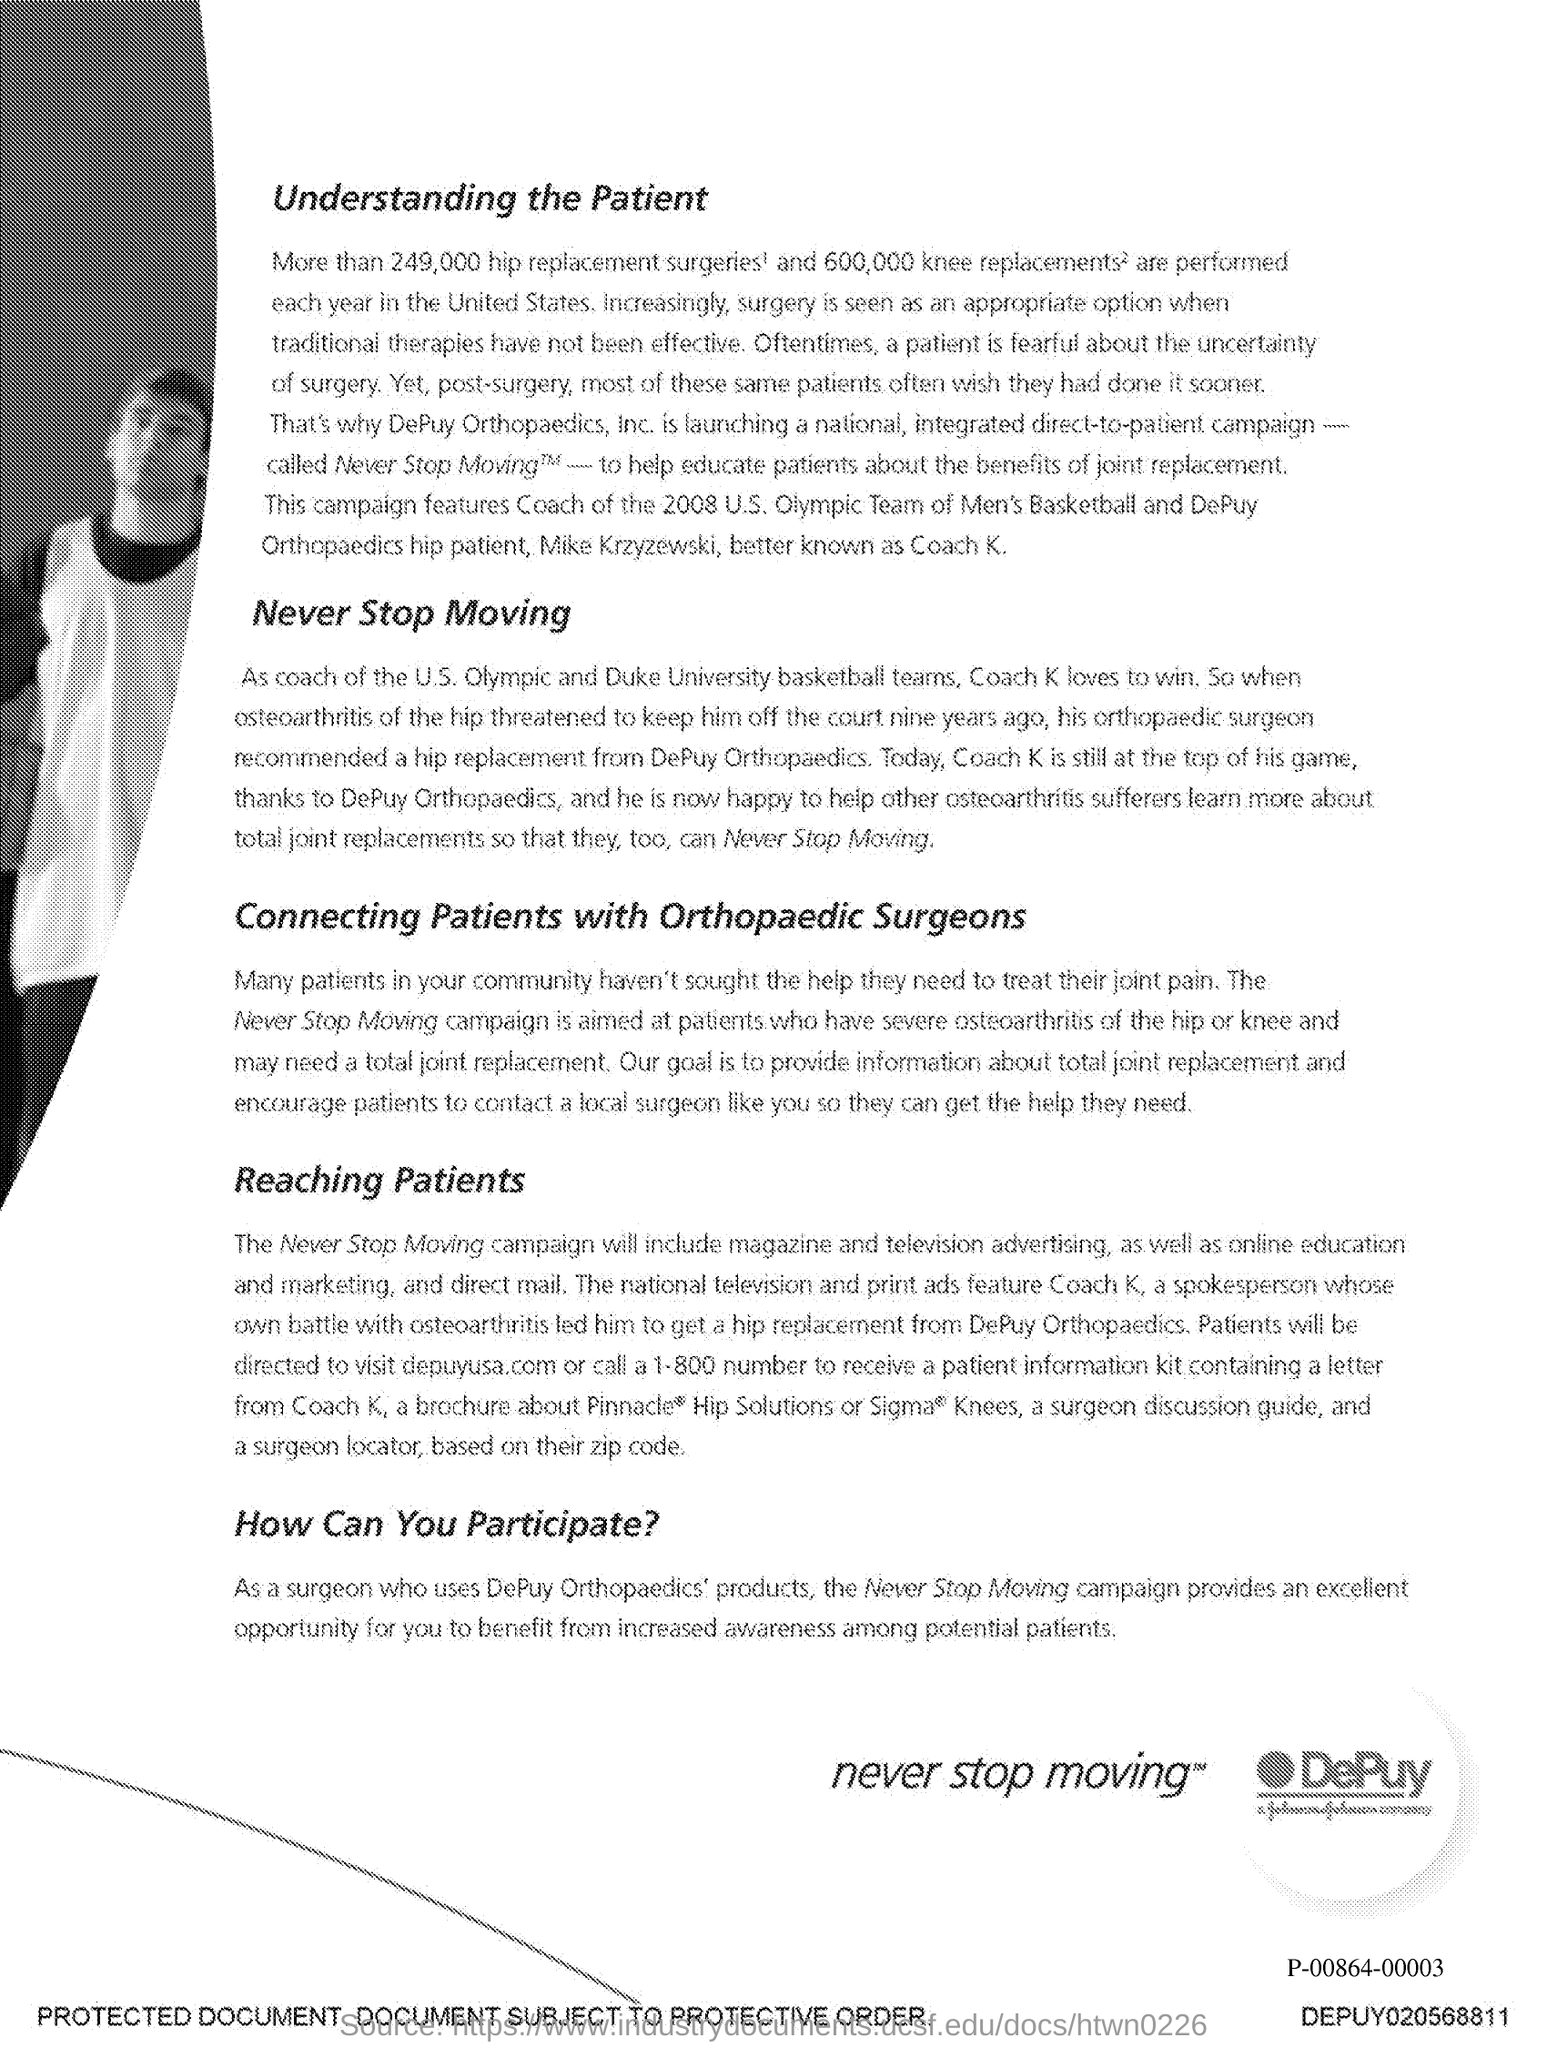Give some essential details in this illustration. The first title in the document is "Understanding the Patient. Never stop moving" is the second title in this document. 